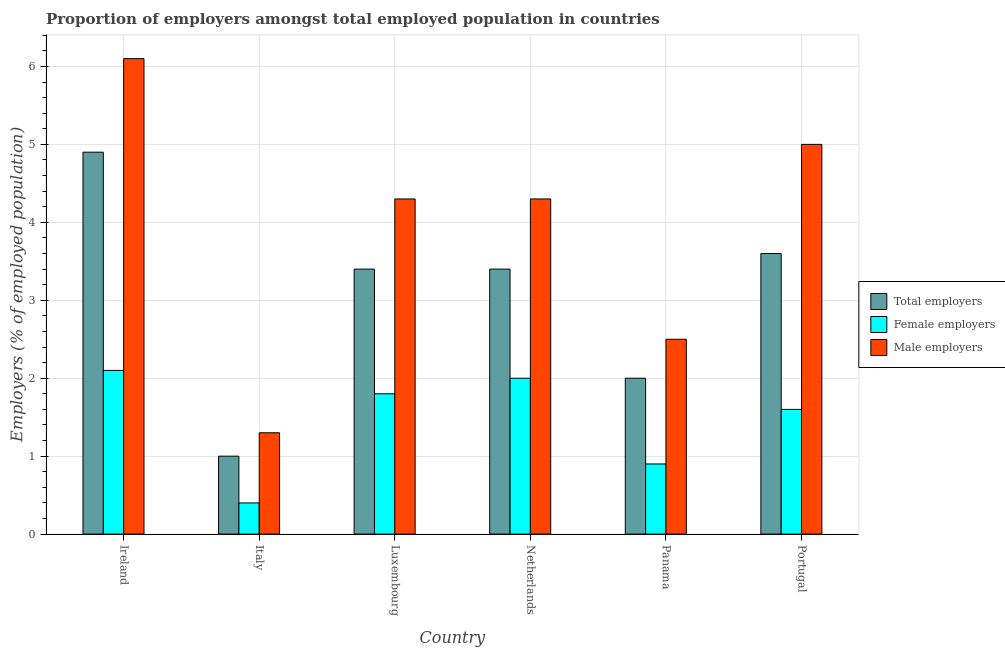How many groups of bars are there?
Offer a very short reply. 6. Are the number of bars per tick equal to the number of legend labels?
Make the answer very short. Yes. How many bars are there on the 5th tick from the left?
Give a very brief answer. 3. What is the label of the 2nd group of bars from the left?
Ensure brevity in your answer.  Italy. What is the percentage of total employers in Ireland?
Offer a terse response. 4.9. Across all countries, what is the maximum percentage of female employers?
Offer a very short reply. 2.1. Across all countries, what is the minimum percentage of total employers?
Ensure brevity in your answer.  1. In which country was the percentage of male employers maximum?
Keep it short and to the point. Ireland. What is the total percentage of total employers in the graph?
Ensure brevity in your answer.  18.3. What is the difference between the percentage of female employers in Ireland and that in Panama?
Your response must be concise. 1.2. What is the difference between the percentage of male employers in Italy and the percentage of female employers in Panama?
Your answer should be very brief. 0.4. What is the average percentage of male employers per country?
Your answer should be very brief. 3.92. What is the difference between the percentage of female employers and percentage of male employers in Luxembourg?
Your answer should be very brief. -2.5. In how many countries, is the percentage of total employers greater than 4.4 %?
Your answer should be very brief. 1. What is the ratio of the percentage of female employers in Ireland to that in Luxembourg?
Provide a succinct answer. 1.17. Is the percentage of male employers in Italy less than that in Netherlands?
Your answer should be very brief. Yes. Is the difference between the percentage of female employers in Netherlands and Portugal greater than the difference between the percentage of male employers in Netherlands and Portugal?
Offer a very short reply. Yes. What is the difference between the highest and the second highest percentage of male employers?
Ensure brevity in your answer.  1.1. What is the difference between the highest and the lowest percentage of total employers?
Offer a terse response. 3.9. What does the 3rd bar from the left in Portugal represents?
Make the answer very short. Male employers. What does the 1st bar from the right in Netherlands represents?
Offer a terse response. Male employers. How many bars are there?
Your response must be concise. 18. What is the difference between two consecutive major ticks on the Y-axis?
Provide a succinct answer. 1. Does the graph contain grids?
Provide a short and direct response. Yes. How are the legend labels stacked?
Your response must be concise. Vertical. What is the title of the graph?
Your answer should be very brief. Proportion of employers amongst total employed population in countries. Does "Primary education" appear as one of the legend labels in the graph?
Give a very brief answer. No. What is the label or title of the X-axis?
Your response must be concise. Country. What is the label or title of the Y-axis?
Ensure brevity in your answer.  Employers (% of employed population). What is the Employers (% of employed population) in Total employers in Ireland?
Your response must be concise. 4.9. What is the Employers (% of employed population) in Female employers in Ireland?
Make the answer very short. 2.1. What is the Employers (% of employed population) in Male employers in Ireland?
Keep it short and to the point. 6.1. What is the Employers (% of employed population) of Total employers in Italy?
Give a very brief answer. 1. What is the Employers (% of employed population) of Female employers in Italy?
Give a very brief answer. 0.4. What is the Employers (% of employed population) in Male employers in Italy?
Offer a terse response. 1.3. What is the Employers (% of employed population) of Total employers in Luxembourg?
Your answer should be very brief. 3.4. What is the Employers (% of employed population) of Female employers in Luxembourg?
Keep it short and to the point. 1.8. What is the Employers (% of employed population) in Male employers in Luxembourg?
Ensure brevity in your answer.  4.3. What is the Employers (% of employed population) in Total employers in Netherlands?
Make the answer very short. 3.4. What is the Employers (% of employed population) in Female employers in Netherlands?
Provide a short and direct response. 2. What is the Employers (% of employed population) in Male employers in Netherlands?
Provide a short and direct response. 4.3. What is the Employers (% of employed population) of Female employers in Panama?
Your answer should be very brief. 0.9. What is the Employers (% of employed population) in Total employers in Portugal?
Ensure brevity in your answer.  3.6. What is the Employers (% of employed population) in Female employers in Portugal?
Provide a succinct answer. 1.6. What is the Employers (% of employed population) in Male employers in Portugal?
Offer a very short reply. 5. Across all countries, what is the maximum Employers (% of employed population) of Total employers?
Your answer should be very brief. 4.9. Across all countries, what is the maximum Employers (% of employed population) of Female employers?
Your answer should be compact. 2.1. Across all countries, what is the maximum Employers (% of employed population) in Male employers?
Provide a succinct answer. 6.1. Across all countries, what is the minimum Employers (% of employed population) in Total employers?
Provide a short and direct response. 1. Across all countries, what is the minimum Employers (% of employed population) in Female employers?
Offer a very short reply. 0.4. Across all countries, what is the minimum Employers (% of employed population) of Male employers?
Your answer should be very brief. 1.3. What is the total Employers (% of employed population) in Total employers in the graph?
Offer a terse response. 18.3. What is the difference between the Employers (% of employed population) in Total employers in Ireland and that in Italy?
Your response must be concise. 3.9. What is the difference between the Employers (% of employed population) of Female employers in Ireland and that in Italy?
Ensure brevity in your answer.  1.7. What is the difference between the Employers (% of employed population) of Female employers in Ireland and that in Luxembourg?
Give a very brief answer. 0.3. What is the difference between the Employers (% of employed population) of Male employers in Ireland and that in Luxembourg?
Give a very brief answer. 1.8. What is the difference between the Employers (% of employed population) in Total employers in Ireland and that in Netherlands?
Offer a terse response. 1.5. What is the difference between the Employers (% of employed population) in Female employers in Ireland and that in Netherlands?
Keep it short and to the point. 0.1. What is the difference between the Employers (% of employed population) of Male employers in Ireland and that in Panama?
Provide a short and direct response. 3.6. What is the difference between the Employers (% of employed population) of Total employers in Ireland and that in Portugal?
Your answer should be compact. 1.3. What is the difference between the Employers (% of employed population) in Female employers in Italy and that in Netherlands?
Offer a terse response. -1.6. What is the difference between the Employers (% of employed population) of Male employers in Italy and that in Netherlands?
Make the answer very short. -3. What is the difference between the Employers (% of employed population) in Male employers in Italy and that in Panama?
Keep it short and to the point. -1.2. What is the difference between the Employers (% of employed population) of Female employers in Italy and that in Portugal?
Offer a terse response. -1.2. What is the difference between the Employers (% of employed population) in Total employers in Luxembourg and that in Netherlands?
Give a very brief answer. 0. What is the difference between the Employers (% of employed population) in Female employers in Luxembourg and that in Netherlands?
Offer a terse response. -0.2. What is the difference between the Employers (% of employed population) in Total employers in Luxembourg and that in Panama?
Provide a succinct answer. 1.4. What is the difference between the Employers (% of employed population) in Female employers in Luxembourg and that in Panama?
Ensure brevity in your answer.  0.9. What is the difference between the Employers (% of employed population) in Total employers in Luxembourg and that in Portugal?
Ensure brevity in your answer.  -0.2. What is the difference between the Employers (% of employed population) of Female employers in Luxembourg and that in Portugal?
Make the answer very short. 0.2. What is the difference between the Employers (% of employed population) in Total employers in Netherlands and that in Panama?
Provide a short and direct response. 1.4. What is the difference between the Employers (% of employed population) of Male employers in Netherlands and that in Panama?
Offer a terse response. 1.8. What is the difference between the Employers (% of employed population) in Male employers in Netherlands and that in Portugal?
Provide a short and direct response. -0.7. What is the difference between the Employers (% of employed population) of Total employers in Panama and that in Portugal?
Provide a succinct answer. -1.6. What is the difference between the Employers (% of employed population) in Female employers in Panama and that in Portugal?
Ensure brevity in your answer.  -0.7. What is the difference between the Employers (% of employed population) in Total employers in Ireland and the Employers (% of employed population) in Female employers in Italy?
Your answer should be compact. 4.5. What is the difference between the Employers (% of employed population) in Total employers in Ireland and the Employers (% of employed population) in Male employers in Italy?
Provide a short and direct response. 3.6. What is the difference between the Employers (% of employed population) of Female employers in Ireland and the Employers (% of employed population) of Male employers in Italy?
Your answer should be very brief. 0.8. What is the difference between the Employers (% of employed population) in Total employers in Ireland and the Employers (% of employed population) in Female employers in Luxembourg?
Offer a very short reply. 3.1. What is the difference between the Employers (% of employed population) in Total employers in Ireland and the Employers (% of employed population) in Male employers in Luxembourg?
Ensure brevity in your answer.  0.6. What is the difference between the Employers (% of employed population) in Female employers in Ireland and the Employers (% of employed population) in Male employers in Netherlands?
Your answer should be very brief. -2.2. What is the difference between the Employers (% of employed population) of Total employers in Ireland and the Employers (% of employed population) of Female employers in Panama?
Keep it short and to the point. 4. What is the difference between the Employers (% of employed population) of Total employers in Ireland and the Employers (% of employed population) of Male employers in Panama?
Keep it short and to the point. 2.4. What is the difference between the Employers (% of employed population) of Female employers in Ireland and the Employers (% of employed population) of Male employers in Panama?
Offer a very short reply. -0.4. What is the difference between the Employers (% of employed population) of Total employers in Ireland and the Employers (% of employed population) of Female employers in Portugal?
Give a very brief answer. 3.3. What is the difference between the Employers (% of employed population) in Female employers in Ireland and the Employers (% of employed population) in Male employers in Portugal?
Your answer should be very brief. -2.9. What is the difference between the Employers (% of employed population) of Total employers in Italy and the Employers (% of employed population) of Female employers in Luxembourg?
Provide a succinct answer. -0.8. What is the difference between the Employers (% of employed population) in Total employers in Italy and the Employers (% of employed population) in Male employers in Netherlands?
Provide a short and direct response. -3.3. What is the difference between the Employers (% of employed population) in Total employers in Italy and the Employers (% of employed population) in Female employers in Panama?
Provide a short and direct response. 0.1. What is the difference between the Employers (% of employed population) in Total employers in Italy and the Employers (% of employed population) in Male employers in Panama?
Offer a very short reply. -1.5. What is the difference between the Employers (% of employed population) in Female employers in Italy and the Employers (% of employed population) in Male employers in Panama?
Make the answer very short. -2.1. What is the difference between the Employers (% of employed population) of Total employers in Italy and the Employers (% of employed population) of Male employers in Portugal?
Offer a terse response. -4. What is the difference between the Employers (% of employed population) in Total employers in Luxembourg and the Employers (% of employed population) in Female employers in Panama?
Your answer should be very brief. 2.5. What is the difference between the Employers (% of employed population) in Total employers in Luxembourg and the Employers (% of employed population) in Male employers in Panama?
Keep it short and to the point. 0.9. What is the difference between the Employers (% of employed population) in Total employers in Netherlands and the Employers (% of employed population) in Female employers in Panama?
Make the answer very short. 2.5. What is the difference between the Employers (% of employed population) of Female employers in Netherlands and the Employers (% of employed population) of Male employers in Panama?
Ensure brevity in your answer.  -0.5. What is the difference between the Employers (% of employed population) in Female employers in Netherlands and the Employers (% of employed population) in Male employers in Portugal?
Your response must be concise. -3. What is the difference between the Employers (% of employed population) in Total employers in Panama and the Employers (% of employed population) in Male employers in Portugal?
Ensure brevity in your answer.  -3. What is the difference between the Employers (% of employed population) in Female employers in Panama and the Employers (% of employed population) in Male employers in Portugal?
Keep it short and to the point. -4.1. What is the average Employers (% of employed population) in Total employers per country?
Your response must be concise. 3.05. What is the average Employers (% of employed population) of Female employers per country?
Provide a succinct answer. 1.47. What is the average Employers (% of employed population) in Male employers per country?
Offer a terse response. 3.92. What is the difference between the Employers (% of employed population) in Total employers and Employers (% of employed population) in Female employers in Luxembourg?
Your answer should be compact. 1.6. What is the difference between the Employers (% of employed population) in Total employers and Employers (% of employed population) in Male employers in Luxembourg?
Offer a terse response. -0.9. What is the difference between the Employers (% of employed population) of Female employers and Employers (% of employed population) of Male employers in Netherlands?
Provide a succinct answer. -2.3. What is the ratio of the Employers (% of employed population) of Total employers in Ireland to that in Italy?
Keep it short and to the point. 4.9. What is the ratio of the Employers (% of employed population) of Female employers in Ireland to that in Italy?
Give a very brief answer. 5.25. What is the ratio of the Employers (% of employed population) in Male employers in Ireland to that in Italy?
Provide a short and direct response. 4.69. What is the ratio of the Employers (% of employed population) in Total employers in Ireland to that in Luxembourg?
Provide a short and direct response. 1.44. What is the ratio of the Employers (% of employed population) of Female employers in Ireland to that in Luxembourg?
Offer a very short reply. 1.17. What is the ratio of the Employers (% of employed population) of Male employers in Ireland to that in Luxembourg?
Your response must be concise. 1.42. What is the ratio of the Employers (% of employed population) of Total employers in Ireland to that in Netherlands?
Keep it short and to the point. 1.44. What is the ratio of the Employers (% of employed population) of Male employers in Ireland to that in Netherlands?
Provide a short and direct response. 1.42. What is the ratio of the Employers (% of employed population) in Total employers in Ireland to that in Panama?
Give a very brief answer. 2.45. What is the ratio of the Employers (% of employed population) in Female employers in Ireland to that in Panama?
Your answer should be compact. 2.33. What is the ratio of the Employers (% of employed population) in Male employers in Ireland to that in Panama?
Offer a terse response. 2.44. What is the ratio of the Employers (% of employed population) of Total employers in Ireland to that in Portugal?
Your answer should be compact. 1.36. What is the ratio of the Employers (% of employed population) in Female employers in Ireland to that in Portugal?
Ensure brevity in your answer.  1.31. What is the ratio of the Employers (% of employed population) in Male employers in Ireland to that in Portugal?
Your response must be concise. 1.22. What is the ratio of the Employers (% of employed population) of Total employers in Italy to that in Luxembourg?
Offer a terse response. 0.29. What is the ratio of the Employers (% of employed population) in Female employers in Italy to that in Luxembourg?
Make the answer very short. 0.22. What is the ratio of the Employers (% of employed population) in Male employers in Italy to that in Luxembourg?
Make the answer very short. 0.3. What is the ratio of the Employers (% of employed population) of Total employers in Italy to that in Netherlands?
Provide a succinct answer. 0.29. What is the ratio of the Employers (% of employed population) of Male employers in Italy to that in Netherlands?
Provide a succinct answer. 0.3. What is the ratio of the Employers (% of employed population) of Female employers in Italy to that in Panama?
Ensure brevity in your answer.  0.44. What is the ratio of the Employers (% of employed population) of Male employers in Italy to that in Panama?
Keep it short and to the point. 0.52. What is the ratio of the Employers (% of employed population) of Total employers in Italy to that in Portugal?
Ensure brevity in your answer.  0.28. What is the ratio of the Employers (% of employed population) of Male employers in Italy to that in Portugal?
Keep it short and to the point. 0.26. What is the ratio of the Employers (% of employed population) of Female employers in Luxembourg to that in Netherlands?
Keep it short and to the point. 0.9. What is the ratio of the Employers (% of employed population) of Male employers in Luxembourg to that in Netherlands?
Give a very brief answer. 1. What is the ratio of the Employers (% of employed population) of Total employers in Luxembourg to that in Panama?
Your answer should be very brief. 1.7. What is the ratio of the Employers (% of employed population) in Female employers in Luxembourg to that in Panama?
Your answer should be very brief. 2. What is the ratio of the Employers (% of employed population) in Male employers in Luxembourg to that in Panama?
Make the answer very short. 1.72. What is the ratio of the Employers (% of employed population) in Total employers in Luxembourg to that in Portugal?
Your response must be concise. 0.94. What is the ratio of the Employers (% of employed population) of Female employers in Luxembourg to that in Portugal?
Your response must be concise. 1.12. What is the ratio of the Employers (% of employed population) of Male employers in Luxembourg to that in Portugal?
Offer a very short reply. 0.86. What is the ratio of the Employers (% of employed population) of Female employers in Netherlands to that in Panama?
Your answer should be very brief. 2.22. What is the ratio of the Employers (% of employed population) of Male employers in Netherlands to that in Panama?
Provide a short and direct response. 1.72. What is the ratio of the Employers (% of employed population) of Male employers in Netherlands to that in Portugal?
Offer a very short reply. 0.86. What is the ratio of the Employers (% of employed population) in Total employers in Panama to that in Portugal?
Offer a terse response. 0.56. What is the ratio of the Employers (% of employed population) in Female employers in Panama to that in Portugal?
Offer a terse response. 0.56. What is the ratio of the Employers (% of employed population) in Male employers in Panama to that in Portugal?
Your answer should be compact. 0.5. What is the difference between the highest and the second highest Employers (% of employed population) of Male employers?
Your answer should be very brief. 1.1. What is the difference between the highest and the lowest Employers (% of employed population) of Total employers?
Provide a succinct answer. 3.9. What is the difference between the highest and the lowest Employers (% of employed population) of Female employers?
Make the answer very short. 1.7. What is the difference between the highest and the lowest Employers (% of employed population) of Male employers?
Offer a very short reply. 4.8. 